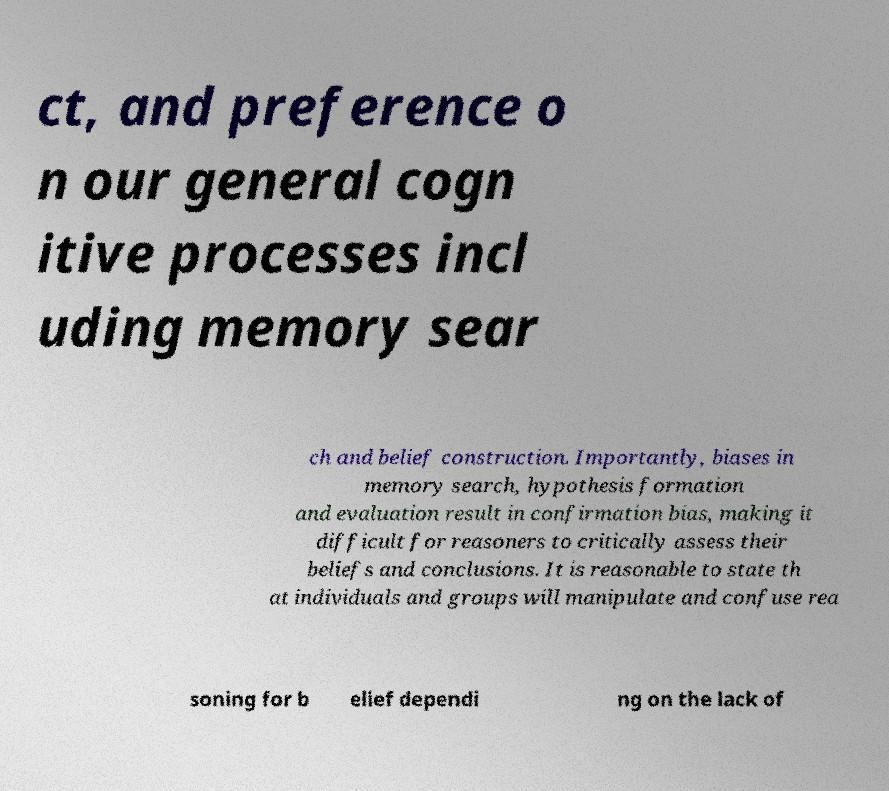Can you read and provide the text displayed in the image?This photo seems to have some interesting text. Can you extract and type it out for me? ct, and preference o n our general cogn itive processes incl uding memory sear ch and belief construction. Importantly, biases in memory search, hypothesis formation and evaluation result in confirmation bias, making it difficult for reasoners to critically assess their beliefs and conclusions. It is reasonable to state th at individuals and groups will manipulate and confuse rea soning for b elief dependi ng on the lack of 